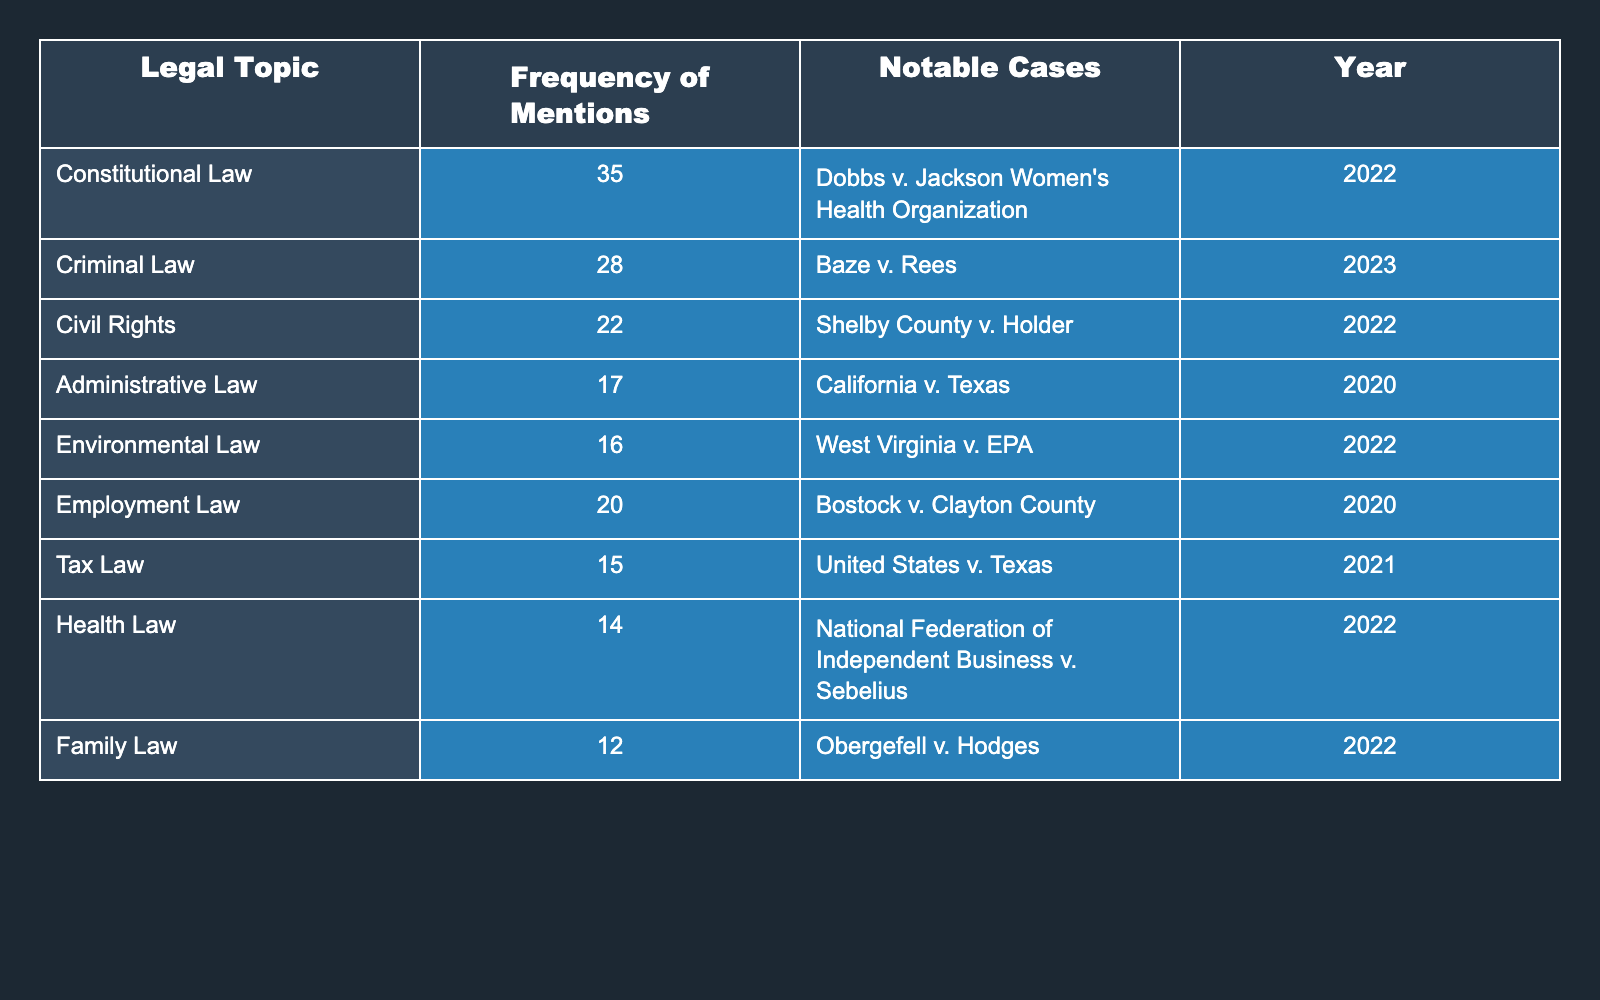What is the most mentioned legal topic in the recent Supreme Court opinions? The table lists the frequencies of mentions for each legal topic. The topic with the highest mention is "Constitutional Law" with 35 mentions.
Answer: Constitutional Law How many mentions does Environmental Law have in comparison to Tax Law? Environmental Law has 16 mentions, while Tax Law has 15 mentions. To compare, Environmental Law has 1 more mention than Tax Law (16 - 15 = 1).
Answer: Environmental Law has 1 more mention Which legal topic has the least frequency of mentions? By reviewing the table, "Family Law" has the least frequency with only 12 mentions.
Answer: Family Law What is the total number of mentions for all legal topics listed? To find the total, we sum all the frequencies: 35 + 28 + 22 + 17 + 16 + 20 + 15 + 14 + 12 =  179.
Answer: 179 Is there a legal topic that has the same frequency of mentions as Employment Law? Employment Law has 20 mentions. Checking the table, no other topic has the same frequency, as the closest is Criminal Law with 28 mentions.
Answer: No What is the average frequency of mentions across all legal topics? Adding all mentions gives 179. There are 9 legal topics, thus the average is 179 / 9 = 19.89, which can be rounded to approximately 20.
Answer: Approximately 20 Which legal topic mentioned in 2022 has fewer mentions than the average frequency? The average frequency is about 20. The topics mentioned in 2022 are "Dobbs v. Jackson Women's Health Organization" (35), "Shelby County v. Holder" (22), and "Health Law" (14) which is less than 20.
Answer: Health Law What is the difference between the mentions of Criminal Law and Family Law? Criminal Law has 28 mentions, while Family Law has 12 mentions. The difference is calculated as 28 - 12 = 16 mentions.
Answer: 16 Are there any legal topics on the list with more than 20 mentions? Yes, by examining the table, we see that "Constitutional Law" (35), "Criminal Law" (28), and "Civil Rights" (22) each have more than 20 mentions.
Answer: Yes List the notable case for Employment Law mentioned in the table. The table indicates that the notable case for Employment Law is "Bostock v. Clayton County."
Answer: Bostock v. Clayton County 